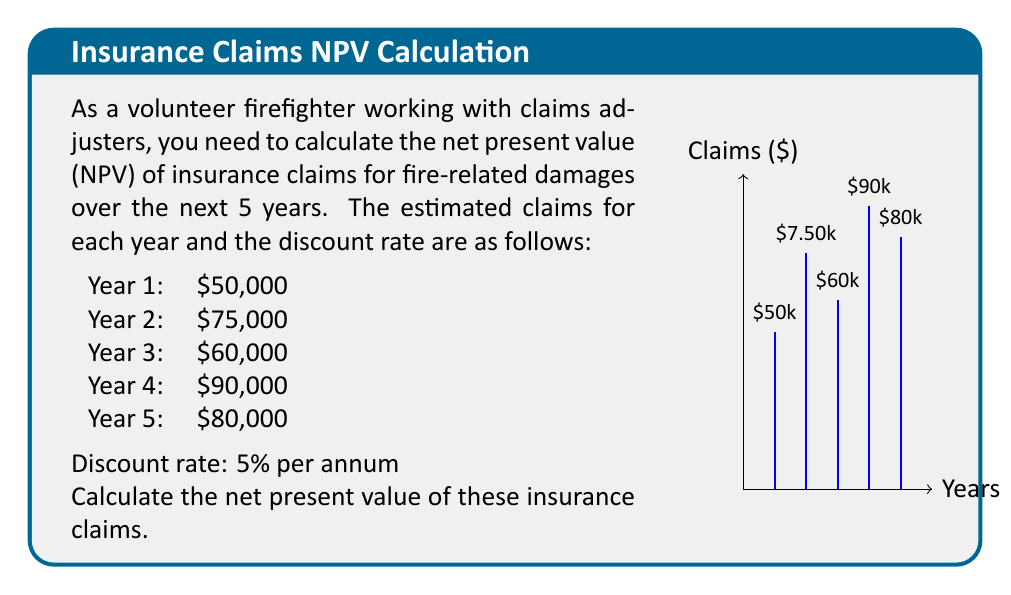Can you solve this math problem? To calculate the net present value (NPV) of the insurance claims, we need to discount each year's claim to its present value and then sum them up. We'll use the NPV formula:

$$NPV = \sum_{t=1}^{n} \frac{C_t}{(1+r)^t}$$

Where:
$C_t$ = Cash flow at time t
$r$ = Discount rate
$n$ = Number of periods

Let's calculate the present value for each year:

Year 1: $\frac{50,000}{(1 + 0.05)^1} = \frac{50,000}{1.05} = 47,619.05$

Year 2: $\frac{75,000}{(1 + 0.05)^2} = \frac{75,000}{1.1025} = 68,027.21$

Year 3: $\frac{60,000}{(1 + 0.05)^3} = \frac{60,000}{1.157625} = 51,830.60$

Year 4: $\frac{90,000}{(1 + 0.05)^4} = \frac{90,000}{1.21550625} = 74,043.32$

Year 5: $\frac{80,000}{(1 + 0.05)^5} = \frac{80,000}{1.2762815625} = 62,681.23$

Now, we sum up all these present values:

$NPV = 47,619.05 + 68,027.21 + 51,830.60 + 74,043.32 + 62,681.23 = 304,201.41$

Therefore, the net present value of the insurance claims is $304,201.41.
Answer: $304,201.41 